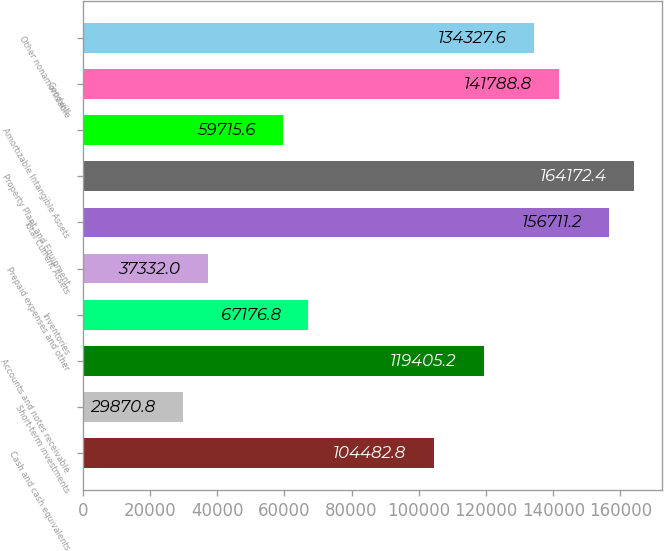Convert chart. <chart><loc_0><loc_0><loc_500><loc_500><bar_chart><fcel>Cash and cash equivalents<fcel>Short-term investments<fcel>Accounts and notes receivable<fcel>Inventories<fcel>Prepaid expenses and other<fcel>Total Current Assets<fcel>Property Plant and Equipment<fcel>Amortizable Intangible Assets<fcel>Goodwill<fcel>Other nonamortizable<nl><fcel>104483<fcel>29870.8<fcel>119405<fcel>67176.8<fcel>37332<fcel>156711<fcel>164172<fcel>59715.6<fcel>141789<fcel>134328<nl></chart> 